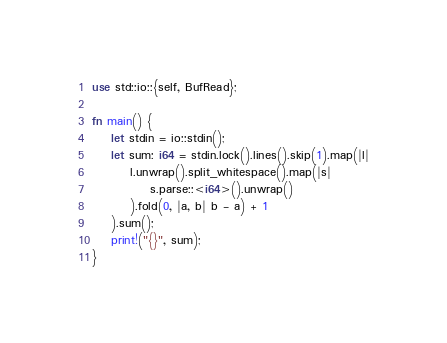<code> <loc_0><loc_0><loc_500><loc_500><_Rust_>use std::io::{self, BufRead};

fn main() {
	let stdin = io::stdin();
	let sum: i64 = stdin.lock().lines().skip(1).map(|l|
		l.unwrap().split_whitespace().map(|s|
			s.parse::<i64>().unwrap()
		).fold(0, |a, b| b - a) + 1
	).sum();
	print!("{}", sum);
}
</code> 